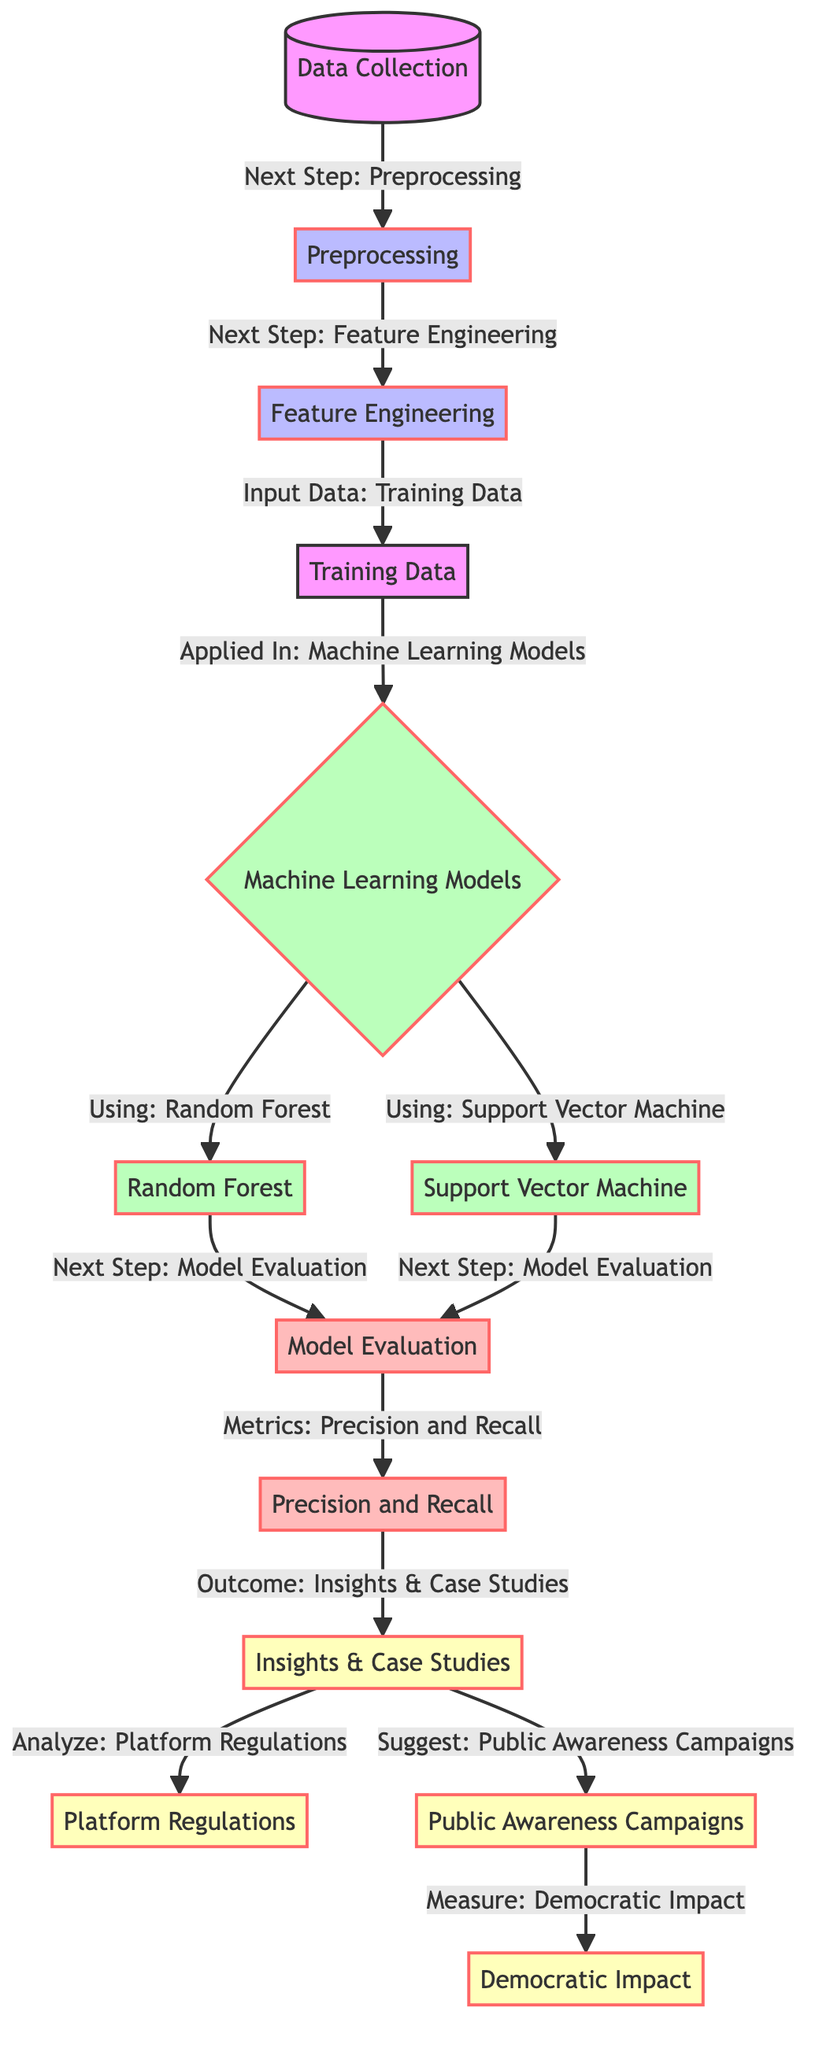What is the first step in the diagram? The first step is labeled "Data Collection," which is the initial action taken in the flow of processing fake news and political misinformation.
Answer: Data Collection How many machine learning models are presented in the diagram? There are two specific machine learning models showcased in the diagram, which are "Random Forest" and "Support Vector Machine."
Answer: 2 What is the next step after "Feature Engineering"? Following "Feature Engineering," the next step is "Training Data," indicating that this phase involves preparing the data for model training.
Answer: Training Data What are the evaluation metrics mentioned in the diagram? The diagram specifies "Precision and Recall" as the metrics used to evaluate the performance of the machine learning models in this context.
Answer: Precision and Recall Which nodes lead to "Insights & Case Studies"? The nodes that directly lead to "Insights & Case Studies" are "Model Evaluation" and specifically the evaluation metrics "Precision and Recall," indicating that these analyses culminate in deriving insights.
Answer: Model Evaluation, Precision and Recall What follows "Model Evaluation" in the process? After "Model Evaluation," the next step involves assessing the evaluation metrics, specifically "Precision and Recall," which are crucial for understanding model performance.
Answer: Precision and Recall Which outcomes result from analyzing "Insights & Case Studies"? The outcomes derived from analyzing "Insights & Case Studies" include "Platform Regulations," "Public Awareness Campaigns," and "Democratic Impact." This shows the potential actions to influence governance and public knowledge based on insights gathered.
Answer: Platform Regulations, Public Awareness Campaigns, Democratic Impact Which process node directly connects to "Support Vector Machine"? The process node that directly connects to "Support Vector Machine" is "Machine Learning Models," indicating that it is one of the specific methodologies applied in the analysis of misinformation.
Answer: Machine Learning Models How are "Platform Regulations" related to "Insights & Case Studies"? "Platform Regulations" is an outcome that emerges from the analysis of "Insights & Case Studies," suggesting that findings from the studies can inform regulatory measures for online platforms dealing with misinformation.
Answer: Analyze 